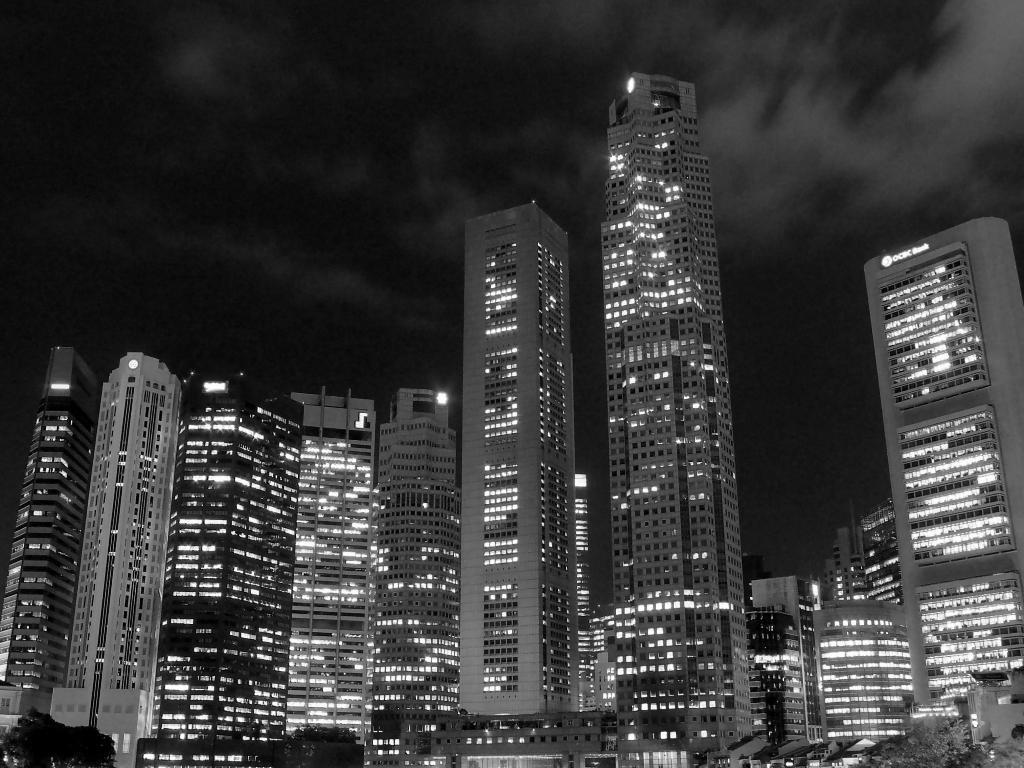What is the color scheme of the image? The image is black and white. What type of structures can be seen in the image? There are buildings in the image. What can be seen illuminating the scene in the image? There are lights visible in the image. How many stalks of celery can be seen in the image? There is no celery present in the image. What color are the eyes of the person in the image? There are no people or eyes visible in the image, as it is a black and white image of buildings and lights. 